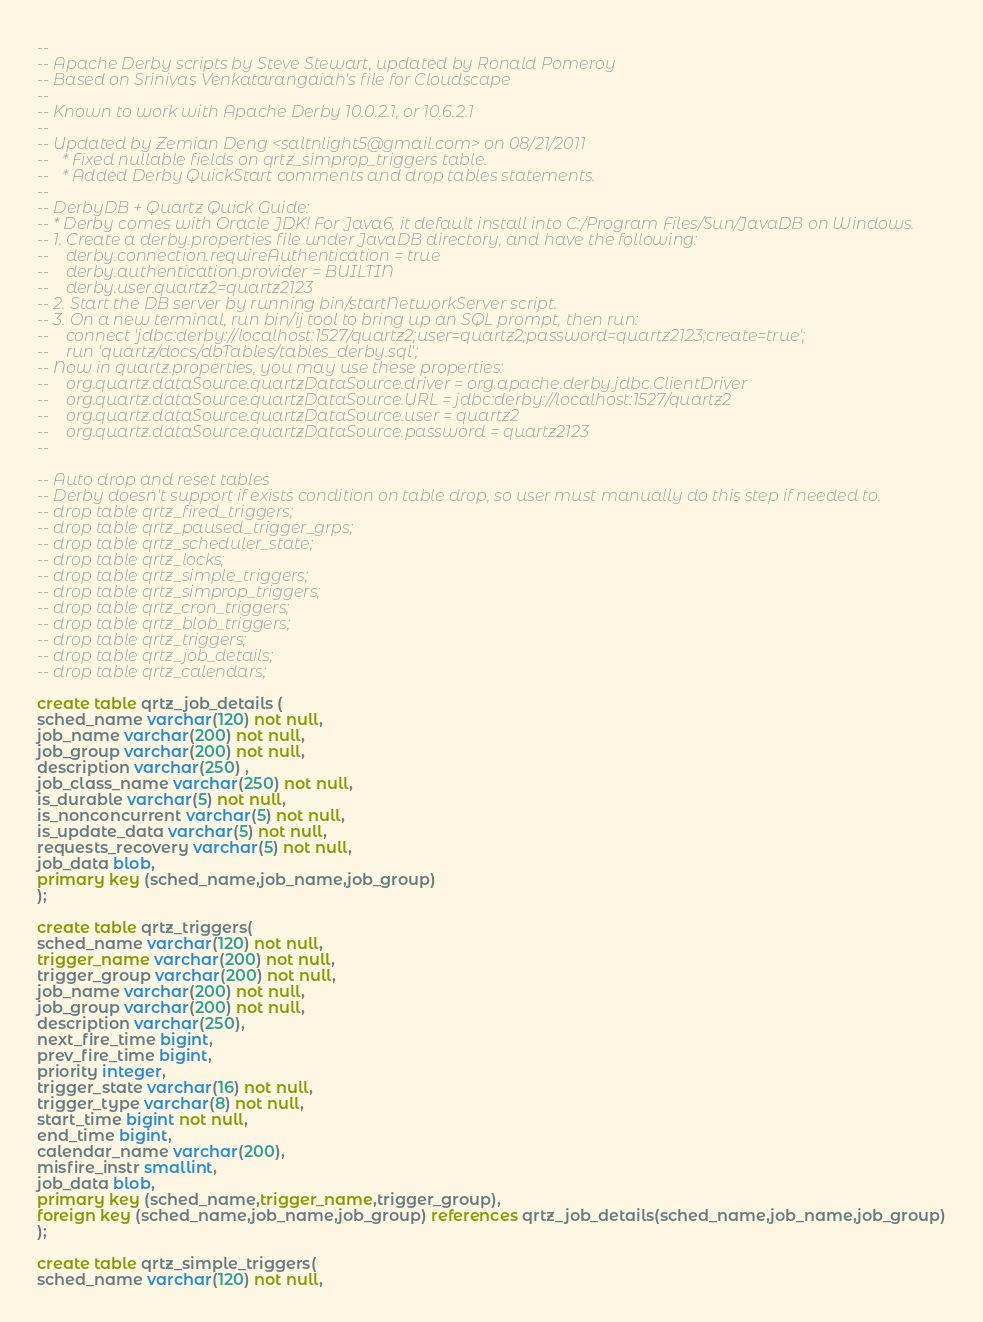<code> <loc_0><loc_0><loc_500><loc_500><_SQL_>-- 
-- Apache Derby scripts by Steve Stewart, updated by Ronald Pomeroy
-- Based on Srinivas Venkatarangaiah's file for Cloudscape
-- 
-- Known to work with Apache Derby 10.0.2.1, or 10.6.2.1
--
-- Updated by Zemian Deng <saltnlight5@gmail.com> on 08/21/2011
--   * Fixed nullable fields on qrtz_simprop_triggers table. 
--   * Added Derby QuickStart comments and drop tables statements.
--
-- DerbyDB + Quartz Quick Guide:
-- * Derby comes with Oracle JDK! For Java6, it default install into C:/Program Files/Sun/JavaDB on Windows.
-- 1. Create a derby.properties file under JavaDB directory, and have the following:
--    derby.connection.requireAuthentication = true
--    derby.authentication.provider = BUILTIN
--    derby.user.quartz2=quartz2123
-- 2. Start the DB server by running bin/startNetworkServer script.
-- 3. On a new terminal, run bin/ij tool to bring up an SQL prompt, then run:
--    connect 'jdbc:derby://localhost:1527/quartz2;user=quartz2;password=quartz2123;create=true';
--    run 'quartz/docs/dbTables/tables_derby.sql';
-- Now in quartz.properties, you may use these properties:
--    org.quartz.dataSource.quartzDataSource.driver = org.apache.derby.jdbc.ClientDriver
--    org.quartz.dataSource.quartzDataSource.URL = jdbc:derby://localhost:1527/quartz2
--    org.quartz.dataSource.quartzDataSource.user = quartz2
--    org.quartz.dataSource.quartzDataSource.password = quartz2123
--

-- Auto drop and reset tables 
-- Derby doesn't support if exists condition on table drop, so user must manually do this step if needed to.
-- drop table qrtz_fired_triggers;
-- drop table qrtz_paused_trigger_grps;
-- drop table qrtz_scheduler_state;
-- drop table qrtz_locks;
-- drop table qrtz_simple_triggers;
-- drop table qrtz_simprop_triggers;
-- drop table qrtz_cron_triggers;
-- drop table qrtz_blob_triggers;
-- drop table qrtz_triggers;
-- drop table qrtz_job_details;
-- drop table qrtz_calendars;

create table qrtz_job_details (
sched_name varchar(120) not null,
job_name varchar(200) not null,
job_group varchar(200) not null,
description varchar(250) ,
job_class_name varchar(250) not null,
is_durable varchar(5) not null,
is_nonconcurrent varchar(5) not null,
is_update_data varchar(5) not null,
requests_recovery varchar(5) not null,
job_data blob,
primary key (sched_name,job_name,job_group)
);

create table qrtz_triggers(
sched_name varchar(120) not null,
trigger_name varchar(200) not null,
trigger_group varchar(200) not null,
job_name varchar(200) not null,
job_group varchar(200) not null,
description varchar(250),
next_fire_time bigint,
prev_fire_time bigint,
priority integer,
trigger_state varchar(16) not null,
trigger_type varchar(8) not null,
start_time bigint not null,
end_time bigint,
calendar_name varchar(200),
misfire_instr smallint,
job_data blob,
primary key (sched_name,trigger_name,trigger_group),
foreign key (sched_name,job_name,job_group) references qrtz_job_details(sched_name,job_name,job_group)
);

create table qrtz_simple_triggers(
sched_name varchar(120) not null,</code> 